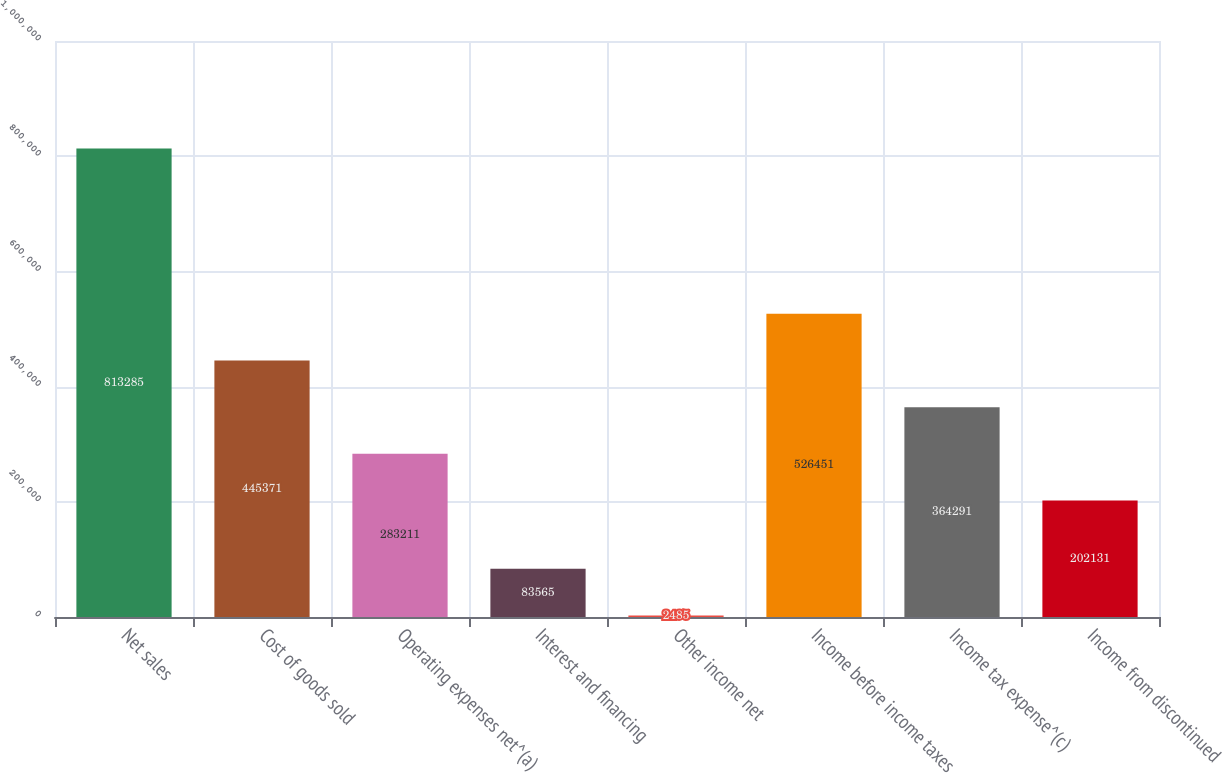Convert chart to OTSL. <chart><loc_0><loc_0><loc_500><loc_500><bar_chart><fcel>Net sales<fcel>Cost of goods sold<fcel>Operating expenses net^(a)<fcel>Interest and financing<fcel>Other income net<fcel>Income before income taxes<fcel>Income tax expense^(c)<fcel>Income from discontinued<nl><fcel>813285<fcel>445371<fcel>283211<fcel>83565<fcel>2485<fcel>526451<fcel>364291<fcel>202131<nl></chart> 